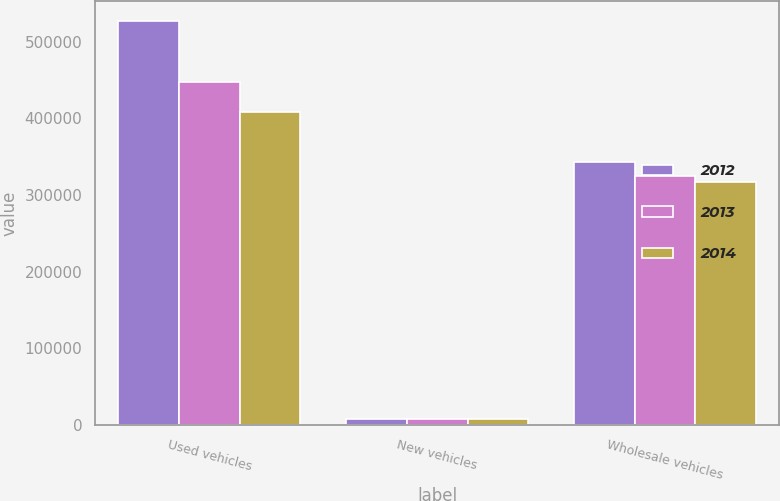<chart> <loc_0><loc_0><loc_500><loc_500><stacked_bar_chart><ecel><fcel>Used vehicles<fcel>New vehicles<fcel>Wholesale vehicles<nl><fcel>2012<fcel>526929<fcel>7761<fcel>342576<nl><fcel>2013<fcel>447728<fcel>7855<fcel>324779<nl><fcel>2014<fcel>408080<fcel>7679<fcel>316649<nl></chart> 